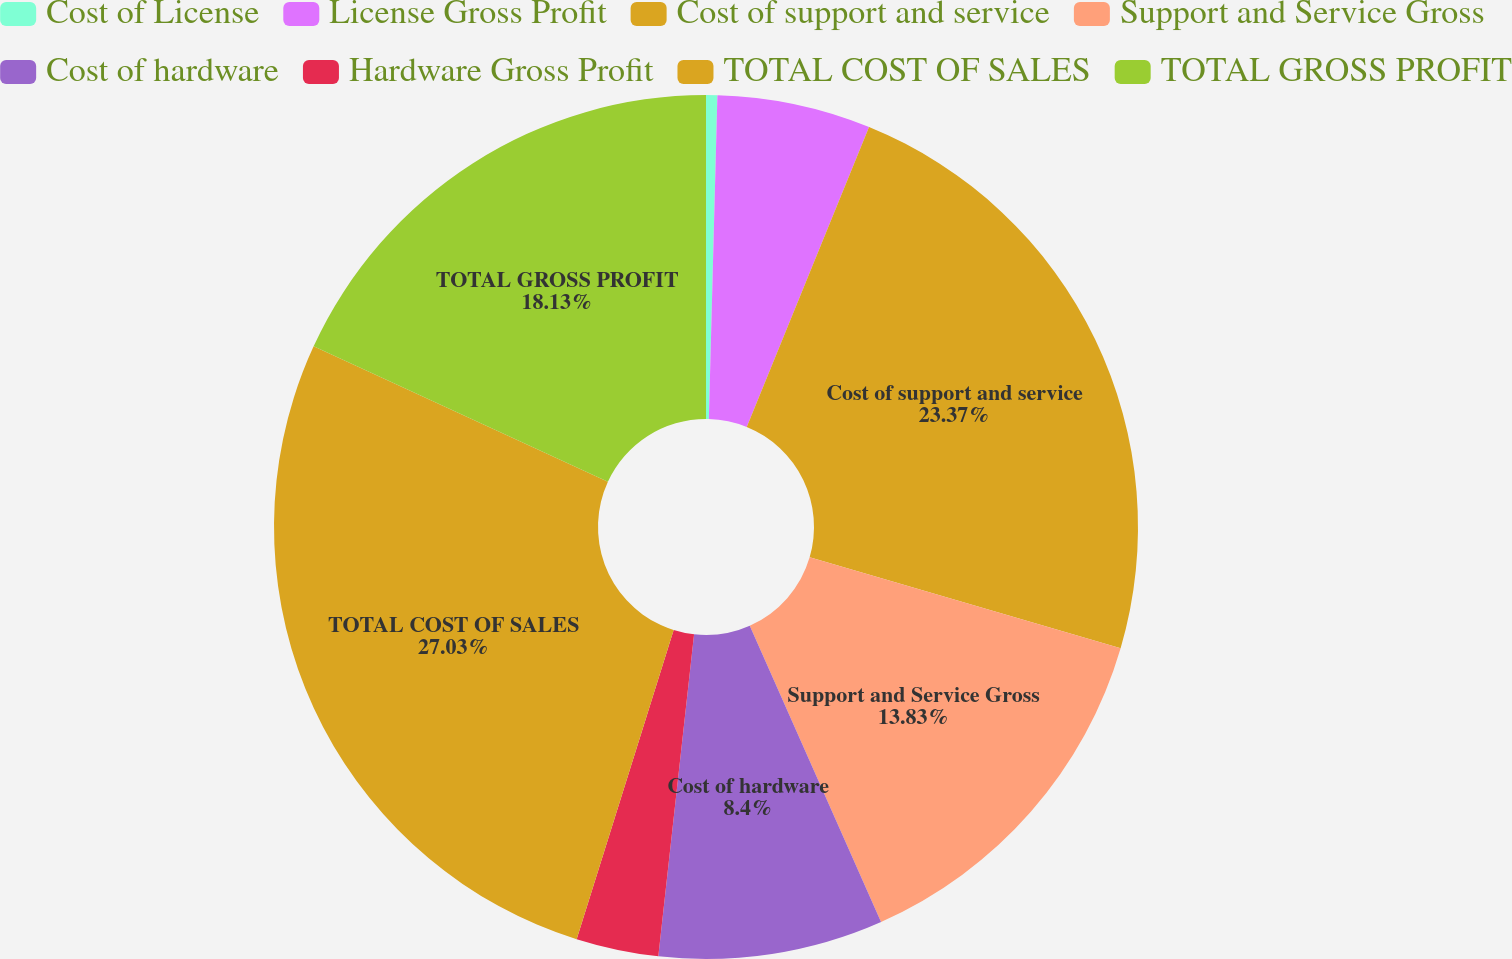<chart> <loc_0><loc_0><loc_500><loc_500><pie_chart><fcel>Cost of License<fcel>License Gross Profit<fcel>Cost of support and service<fcel>Support and Service Gross<fcel>Cost of hardware<fcel>Hardware Gross Profit<fcel>TOTAL COST OF SALES<fcel>TOTAL GROSS PROFIT<nl><fcel>0.42%<fcel>5.74%<fcel>23.37%<fcel>13.83%<fcel>8.4%<fcel>3.08%<fcel>27.03%<fcel>18.13%<nl></chart> 